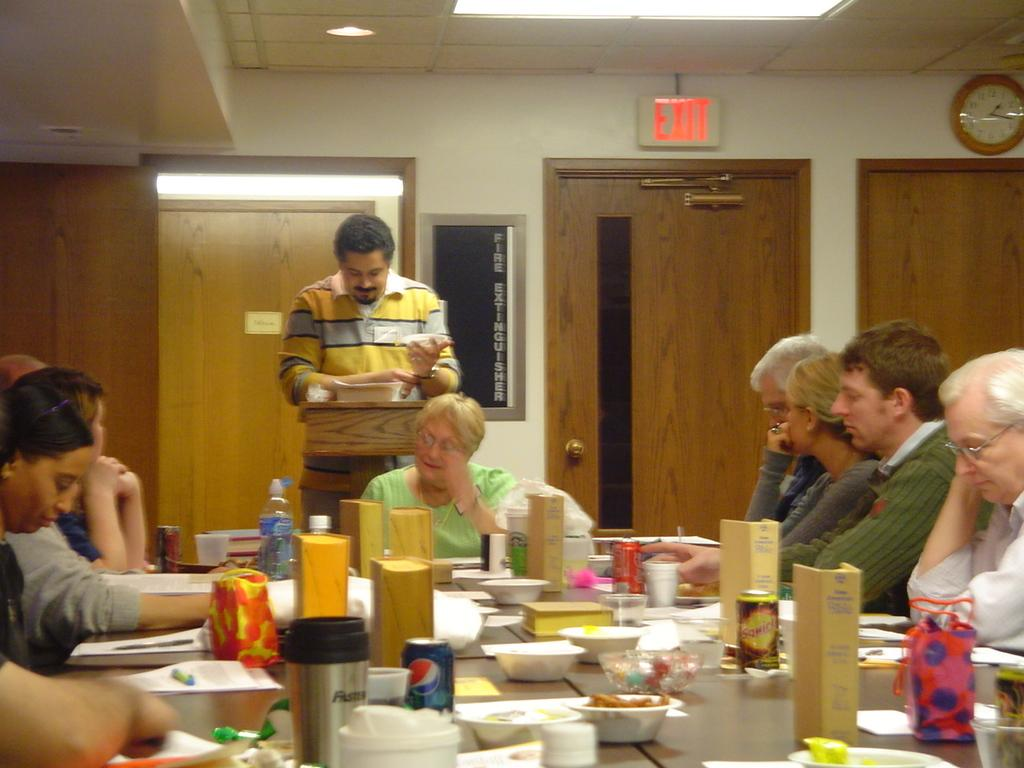What type of structure can be seen in the image? There is a wall in the image. Are there any openings in the wall? Yes, there are doors in the image. What time-related object is present in the image? There is a clock in the image. What type of lighting is present in the image? There is a light in the image. Are there any people in the image? Yes, there are people in the image. What type of furniture is present in the image? There is a table in the image. What items can be found on the table? On the table, there is a tin, a bowl, plates, bottles, papers, and pens. Are there any storage containers in the image? Yes, there are boxes in the image. Reasoning: Let'g: Let's think step by step in order to produce the conversation. We start by identifying the main structures and objects in the image based on the provided facts. We then formulate questions that focus on the location and characteristics of these subjects and objects, ensuring that each question can be answered definitively with the information given. We avoid yes/no questions and ensure that the language is simple and clear. Absurd Question/Answer: What type of goose can be seen flying over the wall in the image? There is no goose present in the image. What is the condition of the night sky in the image? The image does not depict a night sky, so it is not possible to determine the condition of the night sky. What type of goose can be seen flying over the wall in the image? There is no goose present in the image. What is the condition of the night sky in the image? The image does not depict a night sky, so it is not possible to determine the condition of the night sky. 